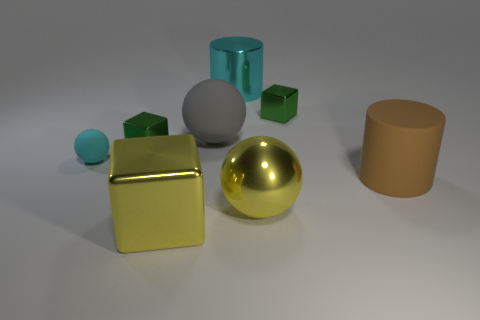How does the texture of the golden sphere compare to the other objects? The golden sphere has a highly reflective, smooth surface that dramatically contrasts with the matte finish of the other objects. Its polished texture allows for a clear mirror-like reflection, emphasizing its distinctness amidst the assortment of geometric shapes. 